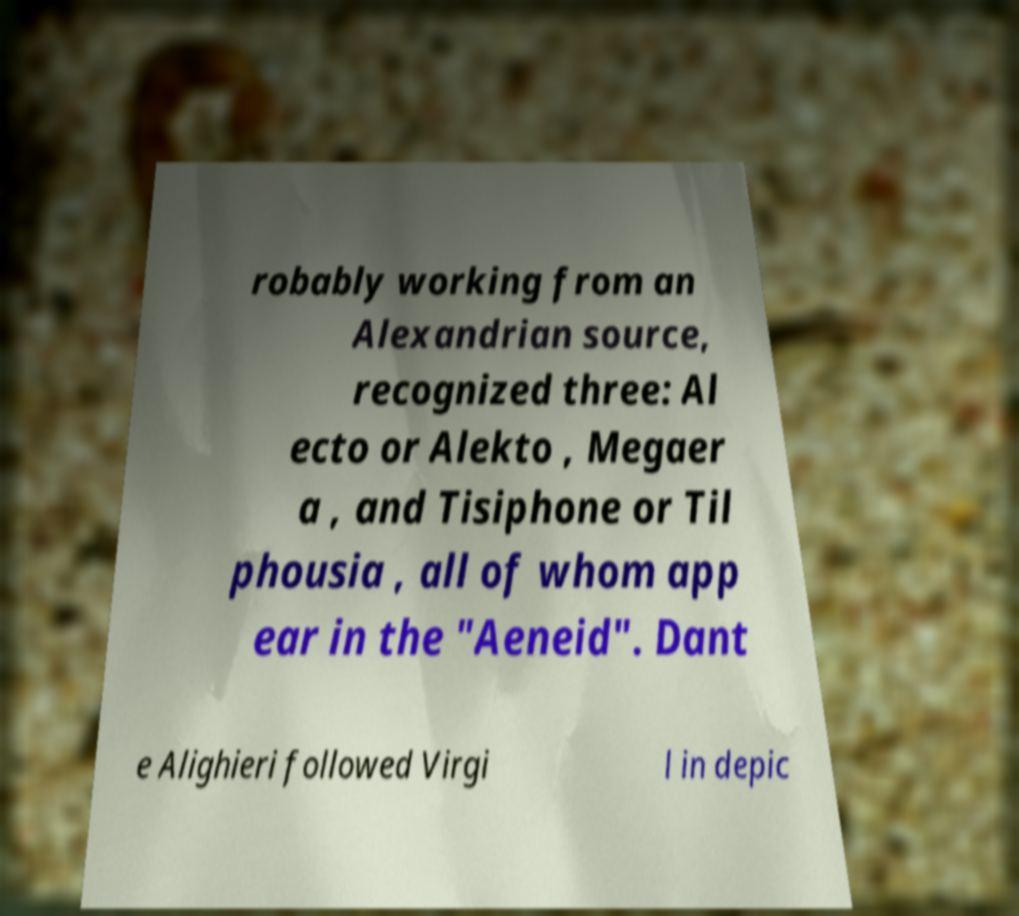I need the written content from this picture converted into text. Can you do that? robably working from an Alexandrian source, recognized three: Al ecto or Alekto , Megaer a , and Tisiphone or Til phousia , all of whom app ear in the "Aeneid". Dant e Alighieri followed Virgi l in depic 